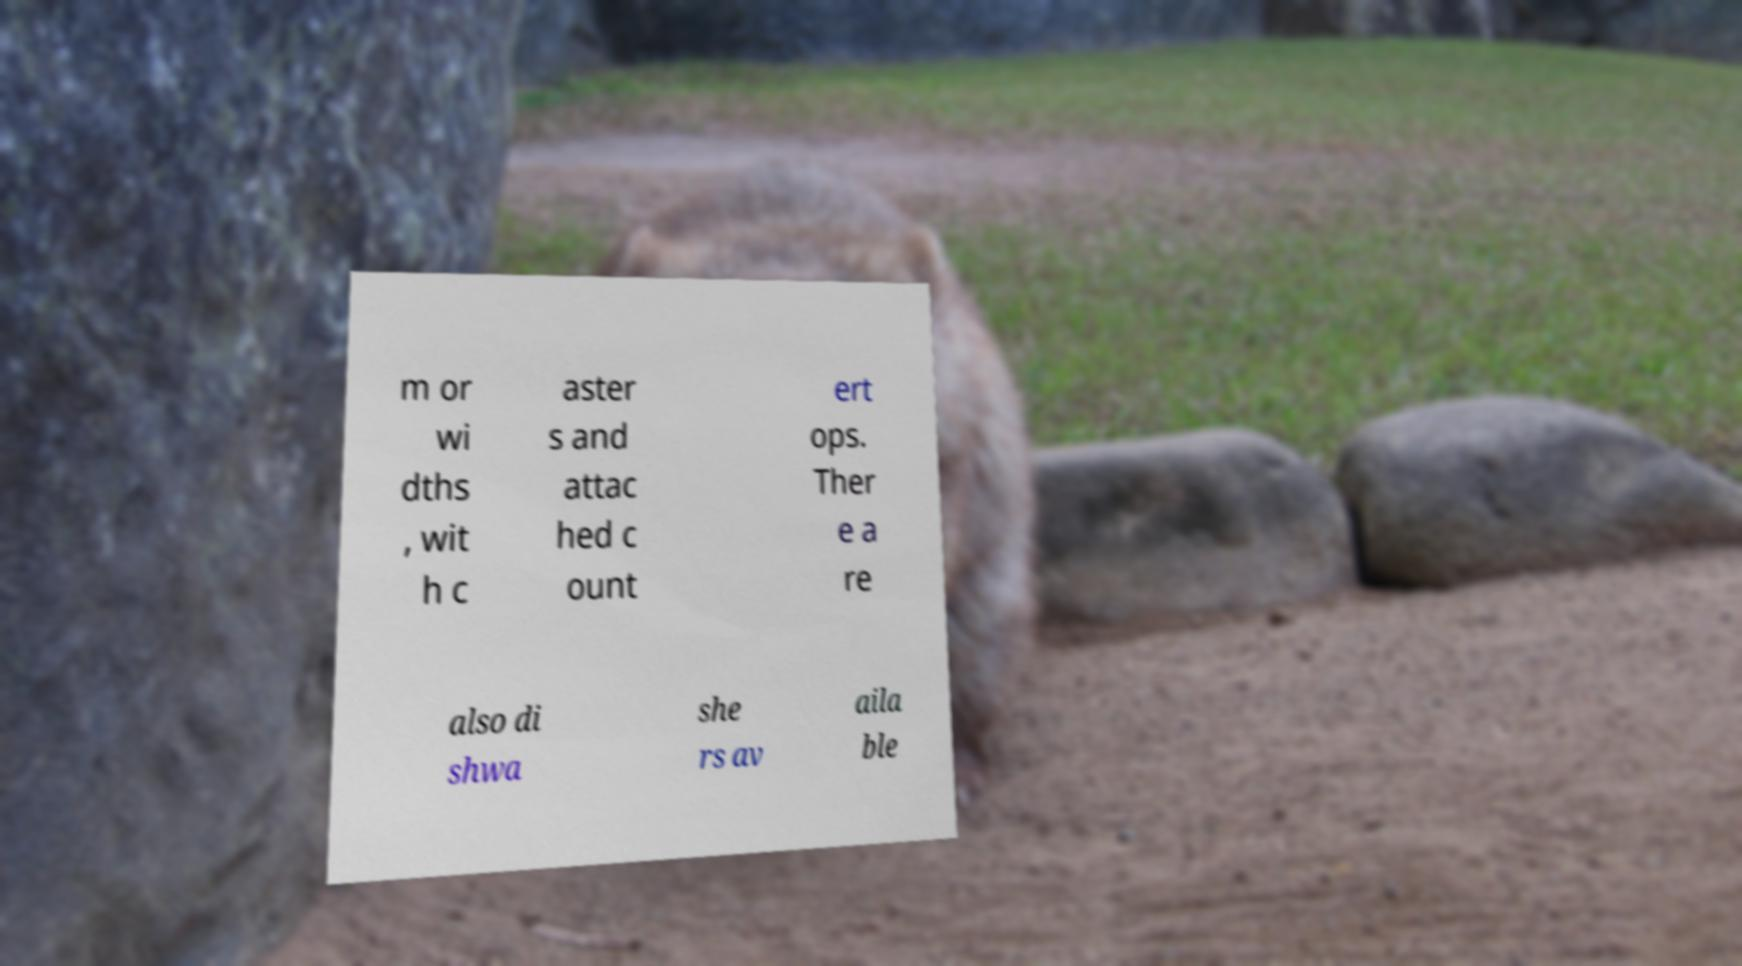Please identify and transcribe the text found in this image. m or wi dths , wit h c aster s and attac hed c ount ert ops. Ther e a re also di shwa she rs av aila ble 